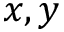<formula> <loc_0><loc_0><loc_500><loc_500>x , y</formula> 